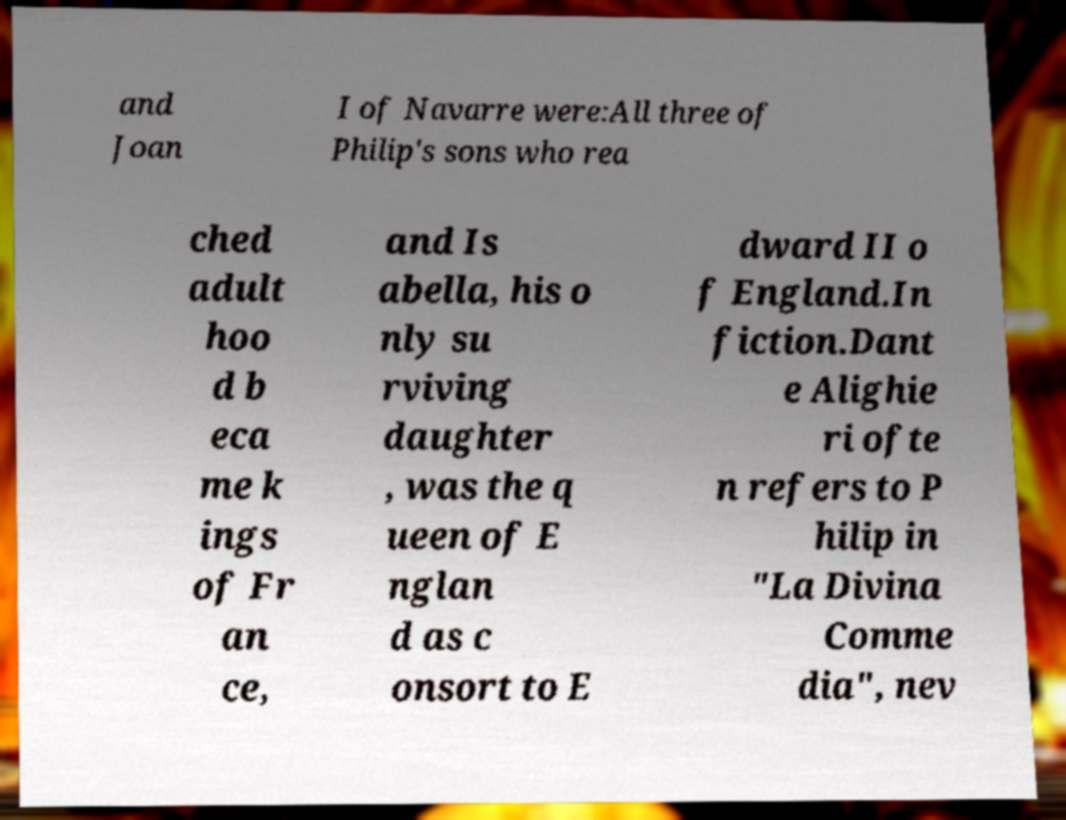Please identify and transcribe the text found in this image. and Joan I of Navarre were:All three of Philip's sons who rea ched adult hoo d b eca me k ings of Fr an ce, and Is abella, his o nly su rviving daughter , was the q ueen of E nglan d as c onsort to E dward II o f England.In fiction.Dant e Alighie ri ofte n refers to P hilip in "La Divina Comme dia", nev 